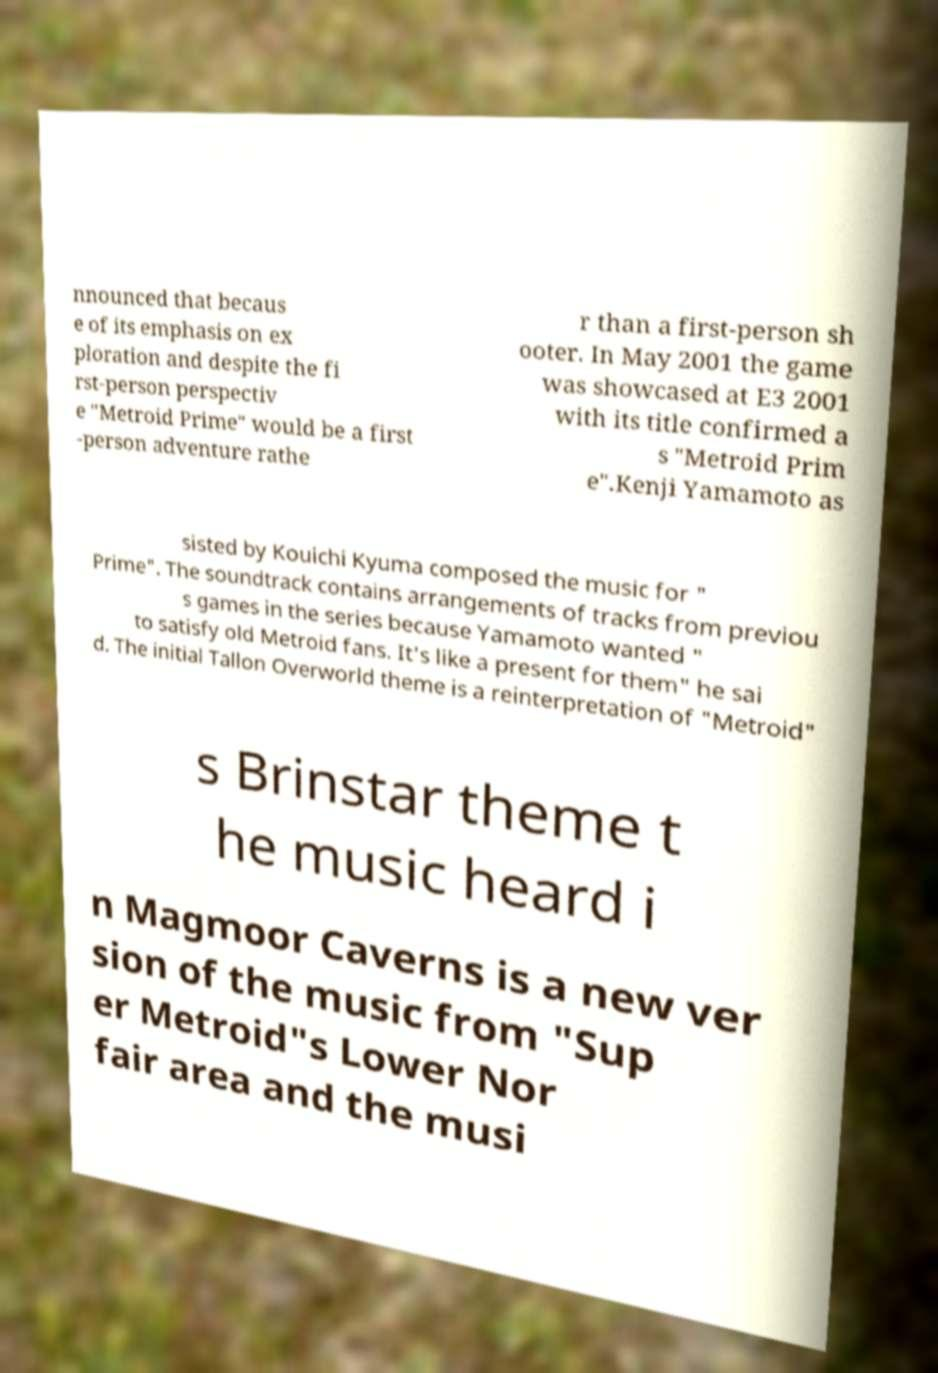Could you extract and type out the text from this image? nnounced that becaus e of its emphasis on ex ploration and despite the fi rst-person perspectiv e "Metroid Prime" would be a first -person adventure rathe r than a first-person sh ooter. In May 2001 the game was showcased at E3 2001 with its title confirmed a s "Metroid Prim e".Kenji Yamamoto as sisted by Kouichi Kyuma composed the music for " Prime". The soundtrack contains arrangements of tracks from previou s games in the series because Yamamoto wanted " to satisfy old Metroid fans. It's like a present for them" he sai d. The initial Tallon Overworld theme is a reinterpretation of "Metroid" s Brinstar theme t he music heard i n Magmoor Caverns is a new ver sion of the music from "Sup er Metroid"s Lower Nor fair area and the musi 